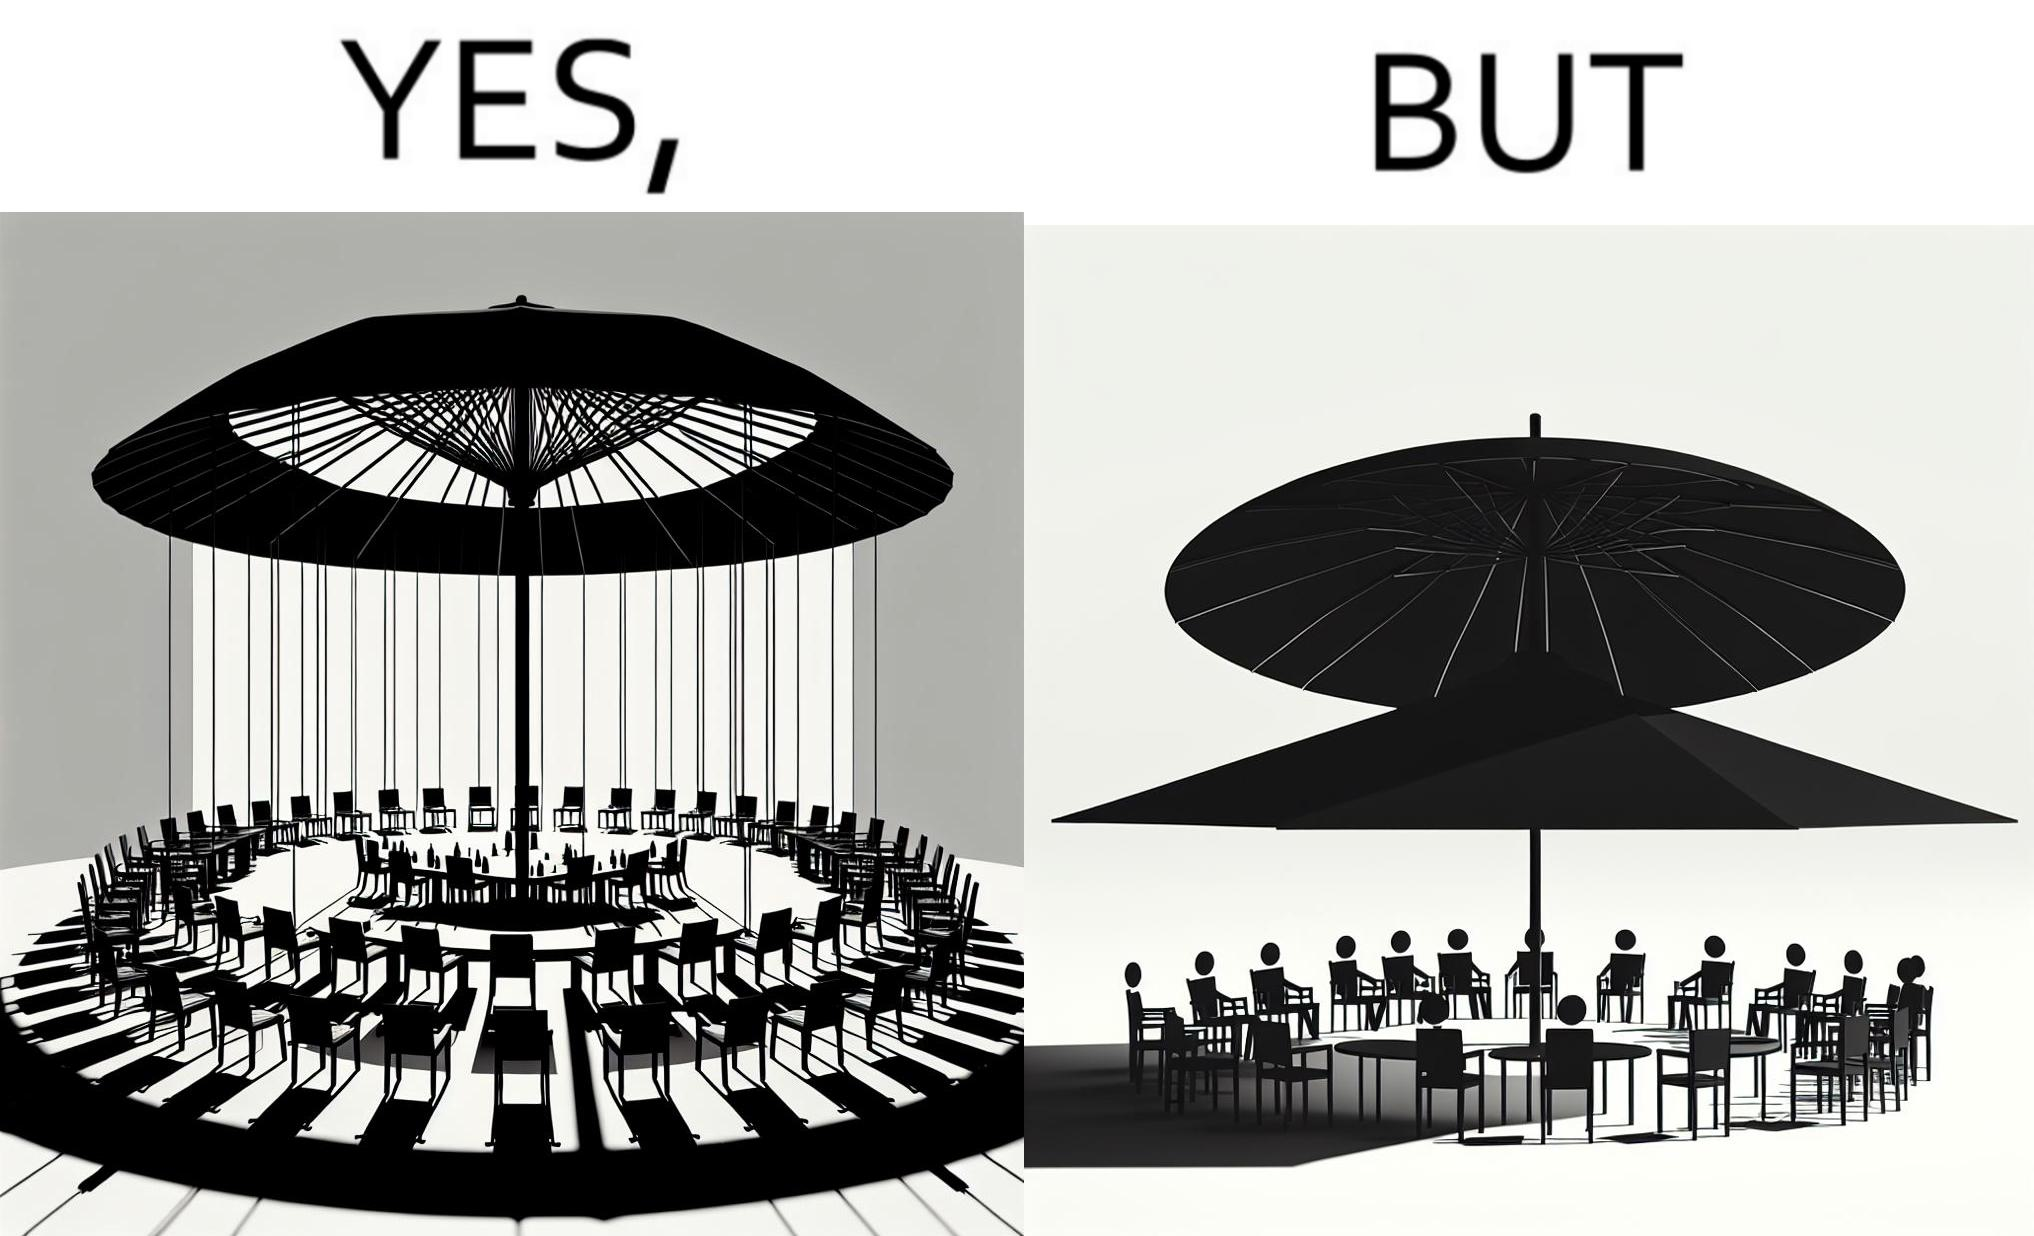Is this image satirical or non-satirical? Yes, this image is satirical. 